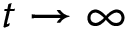<formula> <loc_0><loc_0><loc_500><loc_500>t \rightarrow \infty</formula> 